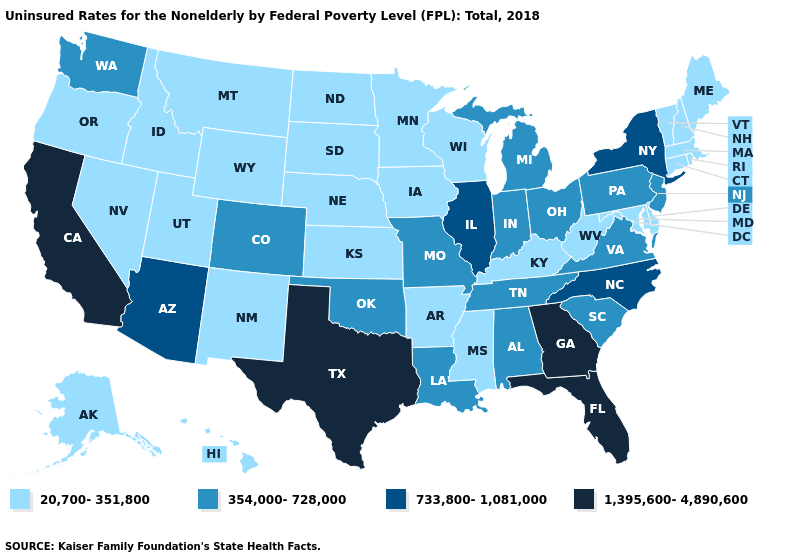Name the states that have a value in the range 354,000-728,000?
Be succinct. Alabama, Colorado, Indiana, Louisiana, Michigan, Missouri, New Jersey, Ohio, Oklahoma, Pennsylvania, South Carolina, Tennessee, Virginia, Washington. Name the states that have a value in the range 354,000-728,000?
Short answer required. Alabama, Colorado, Indiana, Louisiana, Michigan, Missouri, New Jersey, Ohio, Oklahoma, Pennsylvania, South Carolina, Tennessee, Virginia, Washington. Name the states that have a value in the range 1,395,600-4,890,600?
Quick response, please. California, Florida, Georgia, Texas. What is the value of Colorado?
Keep it brief. 354,000-728,000. What is the value of Idaho?
Write a very short answer. 20,700-351,800. Name the states that have a value in the range 1,395,600-4,890,600?
Concise answer only. California, Florida, Georgia, Texas. What is the highest value in the USA?
Write a very short answer. 1,395,600-4,890,600. What is the lowest value in the USA?
Write a very short answer. 20,700-351,800. Among the states that border Colorado , which have the lowest value?
Short answer required. Kansas, Nebraska, New Mexico, Utah, Wyoming. What is the value of Idaho?
Concise answer only. 20,700-351,800. What is the highest value in the West ?
Concise answer only. 1,395,600-4,890,600. Which states have the lowest value in the USA?
Answer briefly. Alaska, Arkansas, Connecticut, Delaware, Hawaii, Idaho, Iowa, Kansas, Kentucky, Maine, Maryland, Massachusetts, Minnesota, Mississippi, Montana, Nebraska, Nevada, New Hampshire, New Mexico, North Dakota, Oregon, Rhode Island, South Dakota, Utah, Vermont, West Virginia, Wisconsin, Wyoming. Among the states that border North Dakota , which have the lowest value?
Answer briefly. Minnesota, Montana, South Dakota. What is the highest value in states that border New York?
Short answer required. 354,000-728,000. Name the states that have a value in the range 20,700-351,800?
Concise answer only. Alaska, Arkansas, Connecticut, Delaware, Hawaii, Idaho, Iowa, Kansas, Kentucky, Maine, Maryland, Massachusetts, Minnesota, Mississippi, Montana, Nebraska, Nevada, New Hampshire, New Mexico, North Dakota, Oregon, Rhode Island, South Dakota, Utah, Vermont, West Virginia, Wisconsin, Wyoming. 